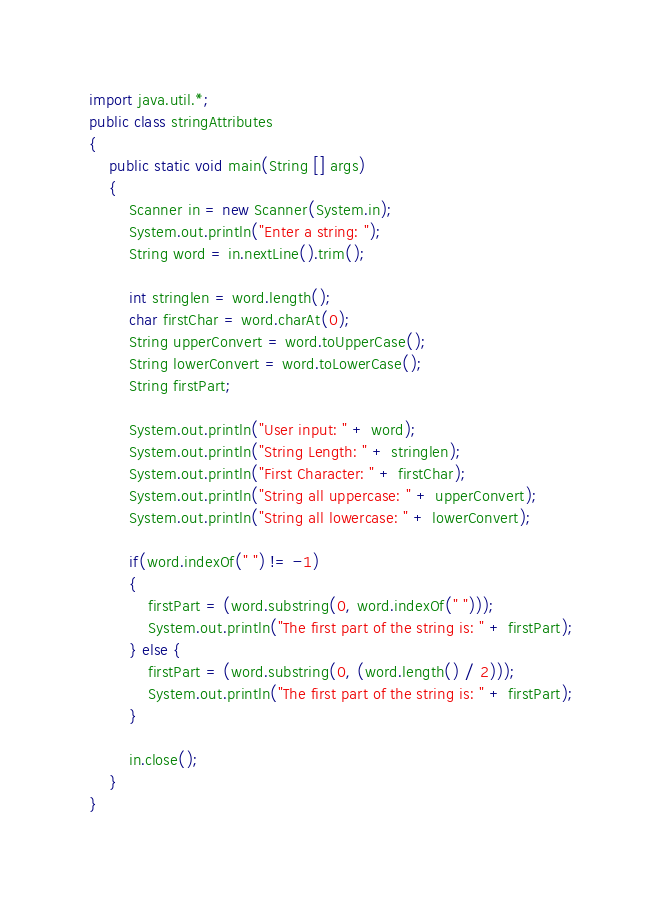<code> <loc_0><loc_0><loc_500><loc_500><_Java_>import java.util.*;
public class stringAttributes 
{
    public static void main(String [] args)
    {
        Scanner in = new Scanner(System.in);
        System.out.println("Enter a string: ");
        String word = in.nextLine().trim();

        int stringlen = word.length();
        char firstChar = word.charAt(0);
        String upperConvert = word.toUpperCase();
        String lowerConvert = word.toLowerCase();
        String firstPart;

        System.out.println("User input: " + word);
        System.out.println("String Length: " + stringlen);
        System.out.println("First Character: " + firstChar);
        System.out.println("String all uppercase: " + upperConvert);
        System.out.println("String all lowercase: " + lowerConvert);
        
        if(word.indexOf(" ") != -1)
        {
            firstPart = (word.substring(0, word.indexOf(" ")));
            System.out.println("The first part of the string is: " + firstPart);
        } else {
            firstPart = (word.substring(0, (word.length() / 2)));
            System.out.println("The first part of the string is: " + firstPart);
        }
        
        in.close();
    }
}</code> 